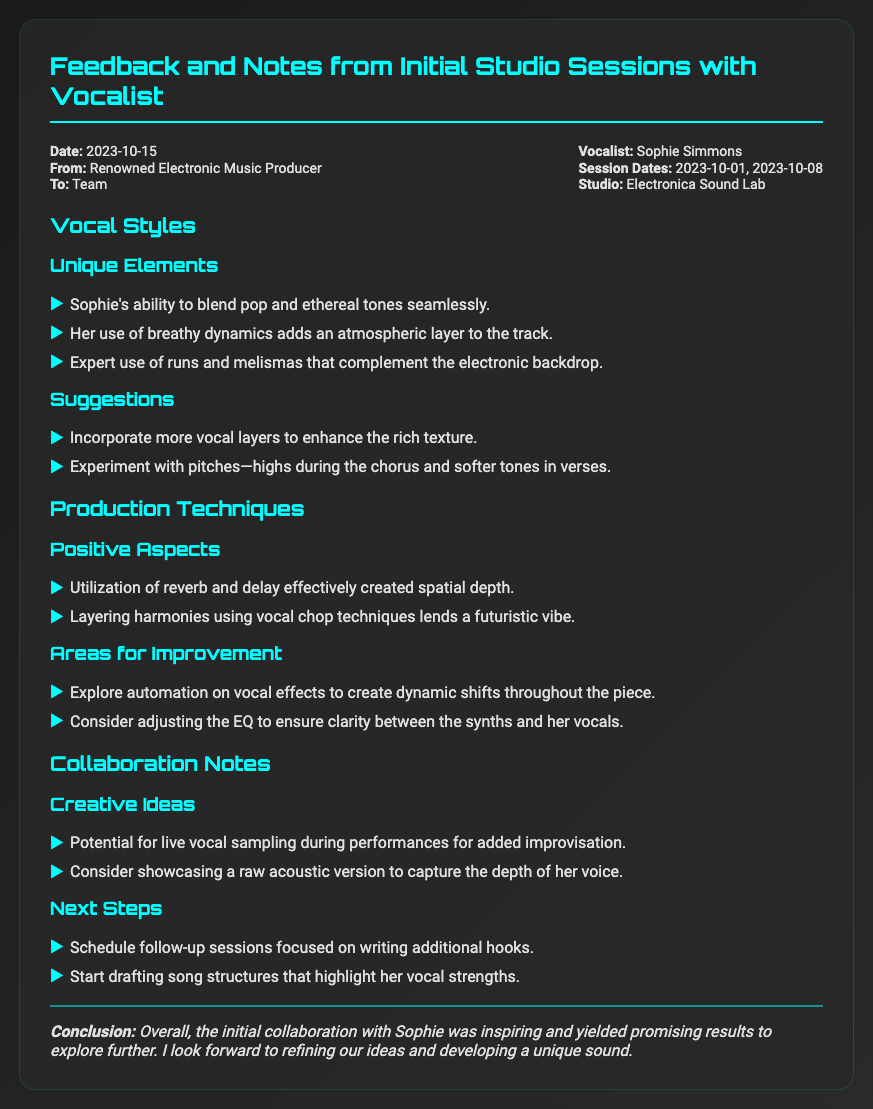what is the date of the memo? The date of the memo is explicitly stated in the document's header.
Answer: 2023-10-15 who is the vocalist mentioned in the memo? The name of the vocalist is provided in the memo header.
Answer: Sophie Simmons what studio was used for the sessions? The studio name is detailed in the header section of the memo.
Answer: Electronica Sound Lab how many sessions took place with the vocalist? The number of sessions is inferred from the session dates listed.
Answer: 2 what unique vocal technique does Sophie use according to the notes? The memo lists specific techniques used by the vocalist under vocal styles.
Answer: Breathy dynamics what is one suggested improvement for the vocal production? Suggestions for enhancing vocal production can be found in the areas for improvement section.
Answer: Explore automation on vocal effects what creative idea is proposed for live performances? Creative ideas for collaboration include various performance techniques noted in the memo.
Answer: Live vocal sampling how is the spatial depth created in the production? The document mentions specific production techniques used to achieve a result.
Answer: Utilization of reverb and delay what is the conclusion regarding the initial collaboration? The conclusion summarizes the overall sentiment towards the collaboration in the memo's final section.
Answer: Inspiring and yielded promising results 